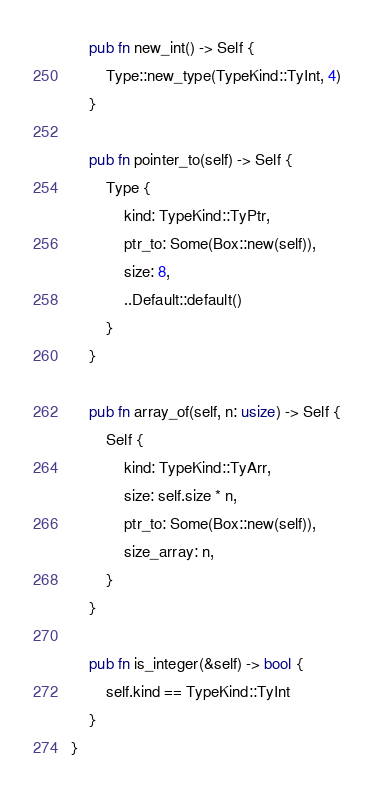Convert code to text. <code><loc_0><loc_0><loc_500><loc_500><_Rust_>    pub fn new_int() -> Self {
        Type::new_type(TypeKind::TyInt, 4)
    }

    pub fn pointer_to(self) -> Self {
        Type {
            kind: TypeKind::TyPtr,
            ptr_to: Some(Box::new(self)),
            size: 8,
            ..Default::default()
        }
    }

    pub fn array_of(self, n: usize) -> Self {
        Self {
            kind: TypeKind::TyArr,
            size: self.size * n,
            ptr_to: Some(Box::new(self)),
            size_array: n,
        }
    }

    pub fn is_integer(&self) -> bool {
        self.kind == TypeKind::TyInt
    }
}
</code> 